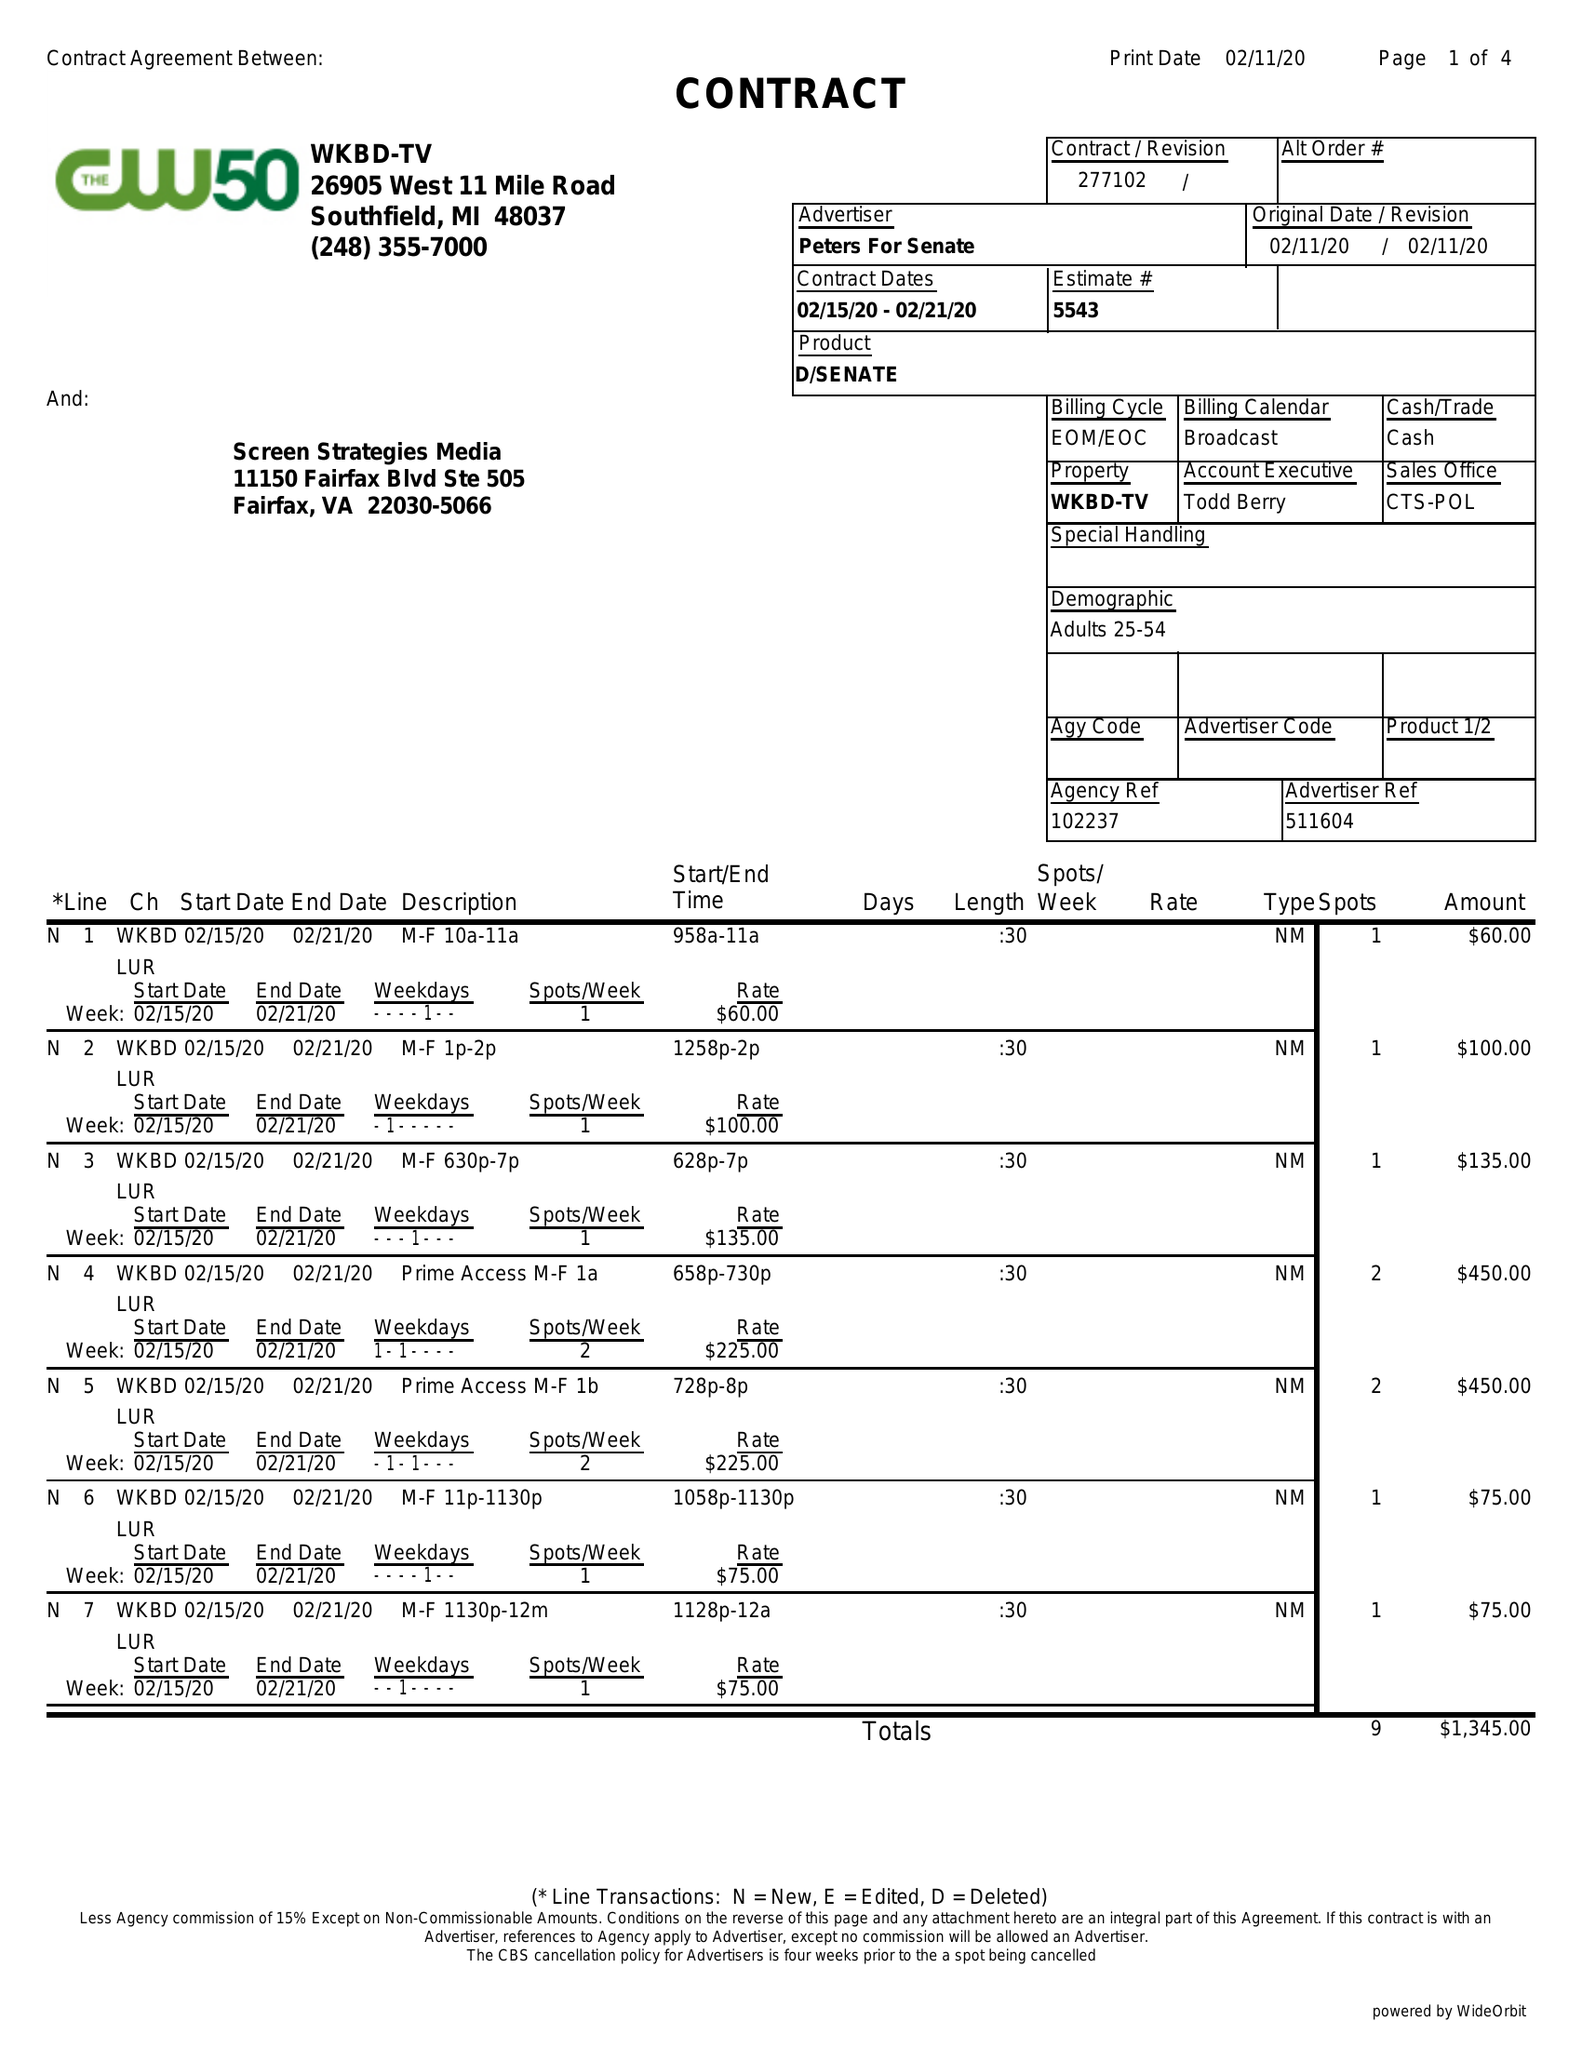What is the value for the flight_to?
Answer the question using a single word or phrase. 02/21/20 